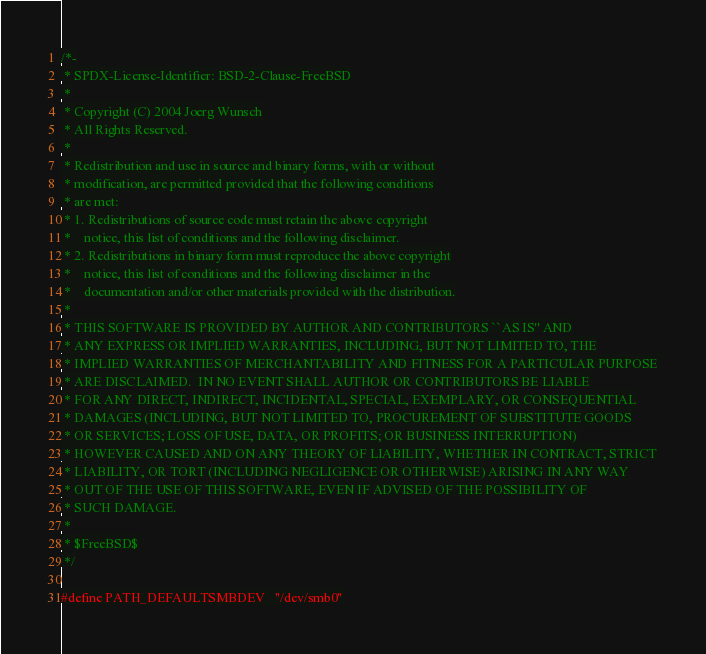<code> <loc_0><loc_0><loc_500><loc_500><_C_>/*-
 * SPDX-License-Identifier: BSD-2-Clause-FreeBSD
 *
 * Copyright (C) 2004 Joerg Wunsch
 * All Rights Reserved.
 *
 * Redistribution and use in source and binary forms, with or without
 * modification, are permitted provided that the following conditions
 * are met:
 * 1. Redistributions of source code must retain the above copyright
 *    notice, this list of conditions and the following disclaimer.
 * 2. Redistributions in binary form must reproduce the above copyright
 *    notice, this list of conditions and the following disclaimer in the
 *    documentation and/or other materials provided with the distribution.
 *
 * THIS SOFTWARE IS PROVIDED BY AUTHOR AND CONTRIBUTORS ``AS IS'' AND
 * ANY EXPRESS OR IMPLIED WARRANTIES, INCLUDING, BUT NOT LIMITED TO, THE
 * IMPLIED WARRANTIES OF MERCHANTABILITY AND FITNESS FOR A PARTICULAR PURPOSE
 * ARE DISCLAIMED.  IN NO EVENT SHALL AUTHOR OR CONTRIBUTORS BE LIABLE
 * FOR ANY DIRECT, INDIRECT, INCIDENTAL, SPECIAL, EXEMPLARY, OR CONSEQUENTIAL
 * DAMAGES (INCLUDING, BUT NOT LIMITED TO, PROCUREMENT OF SUBSTITUTE GOODS
 * OR SERVICES; LOSS OF USE, DATA, OR PROFITS; OR BUSINESS INTERRUPTION)
 * HOWEVER CAUSED AND ON ANY THEORY OF LIABILITY, WHETHER IN CONTRACT, STRICT
 * LIABILITY, OR TORT (INCLUDING NEGLIGENCE OR OTHERWISE) ARISING IN ANY WAY
 * OUT OF THE USE OF THIS SOFTWARE, EVEN IF ADVISED OF THE POSSIBILITY OF
 * SUCH DAMAGE.
 *
 * $FreeBSD$
 */

#define PATH_DEFAULTSMBDEV	"/dev/smb0"
</code> 